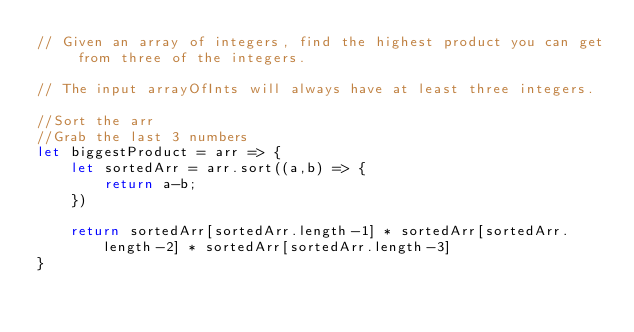<code> <loc_0><loc_0><loc_500><loc_500><_JavaScript_>// Given an array of integers, find the highest product you can get from three of the integers.

// The input arrayOfInts will always have at least three integers.

//Sort the arr
//Grab the last 3 numbers
let biggestProduct = arr => {
    let sortedArr = arr.sort((a,b) => {
        return a-b;
    })

    return sortedArr[sortedArr.length-1] * sortedArr[sortedArr.length-2] * sortedArr[sortedArr.length-3]
}</code> 